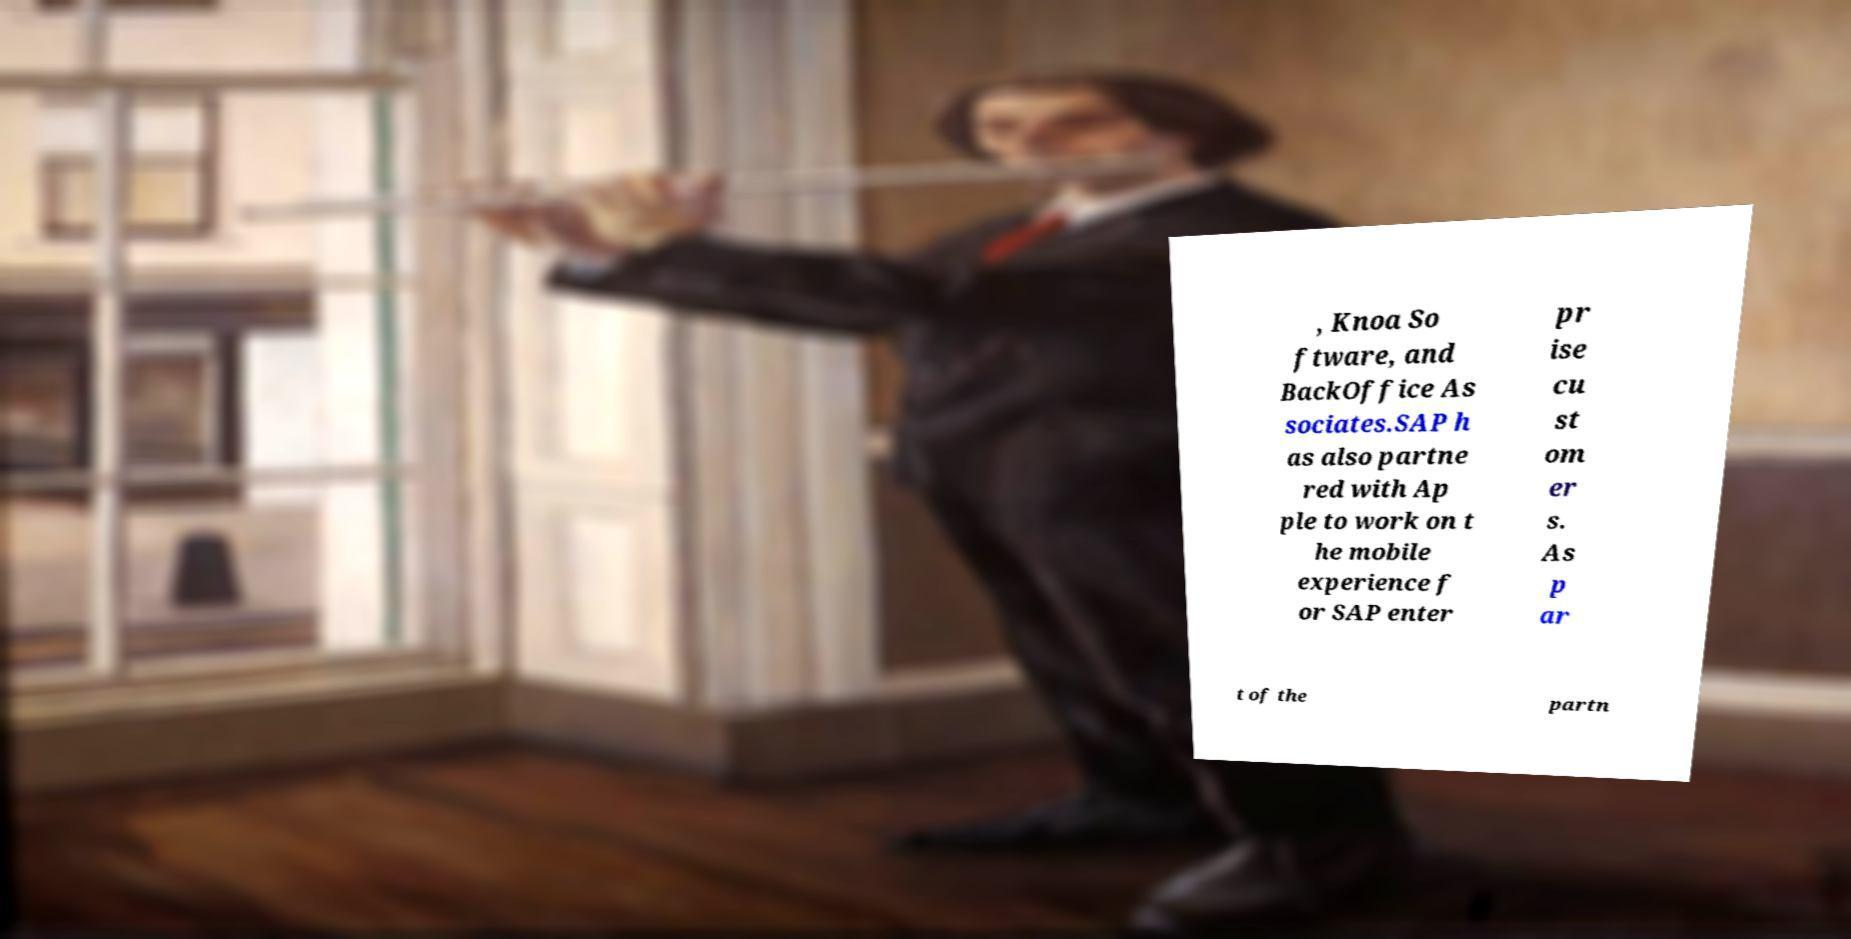I need the written content from this picture converted into text. Can you do that? , Knoa So ftware, and BackOffice As sociates.SAP h as also partne red with Ap ple to work on t he mobile experience f or SAP enter pr ise cu st om er s. As p ar t of the partn 